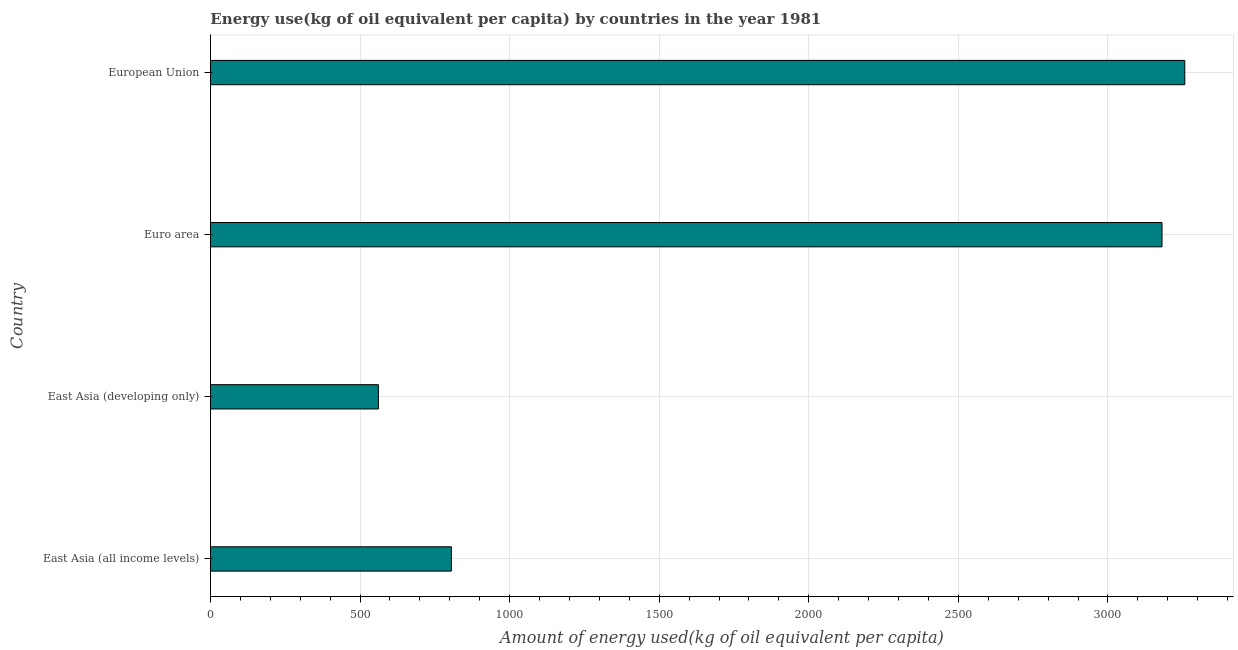Does the graph contain any zero values?
Give a very brief answer. No. What is the title of the graph?
Make the answer very short. Energy use(kg of oil equivalent per capita) by countries in the year 1981. What is the label or title of the X-axis?
Keep it short and to the point. Amount of energy used(kg of oil equivalent per capita). What is the amount of energy used in European Union?
Offer a very short reply. 3256.81. Across all countries, what is the maximum amount of energy used?
Offer a terse response. 3256.81. Across all countries, what is the minimum amount of energy used?
Your answer should be very brief. 561.29. In which country was the amount of energy used maximum?
Make the answer very short. European Union. In which country was the amount of energy used minimum?
Offer a very short reply. East Asia (developing only). What is the sum of the amount of energy used?
Provide a succinct answer. 7804.25. What is the difference between the amount of energy used in East Asia (all income levels) and European Union?
Give a very brief answer. -2451.39. What is the average amount of energy used per country?
Your response must be concise. 1951.06. What is the median amount of energy used?
Offer a terse response. 1993.07. In how many countries, is the amount of energy used greater than 1600 kg?
Provide a short and direct response. 2. What is the ratio of the amount of energy used in East Asia (all income levels) to that in East Asia (developing only)?
Your answer should be very brief. 1.44. Is the difference between the amount of energy used in East Asia (all income levels) and European Union greater than the difference between any two countries?
Keep it short and to the point. No. What is the difference between the highest and the second highest amount of energy used?
Your answer should be compact. 76.08. What is the difference between the highest and the lowest amount of energy used?
Ensure brevity in your answer.  2695.52. How many bars are there?
Keep it short and to the point. 4. What is the difference between two consecutive major ticks on the X-axis?
Make the answer very short. 500. Are the values on the major ticks of X-axis written in scientific E-notation?
Your response must be concise. No. What is the Amount of energy used(kg of oil equivalent per capita) of East Asia (all income levels)?
Give a very brief answer. 805.42. What is the Amount of energy used(kg of oil equivalent per capita) in East Asia (developing only)?
Your answer should be very brief. 561.29. What is the Amount of energy used(kg of oil equivalent per capita) in Euro area?
Give a very brief answer. 3180.73. What is the Amount of energy used(kg of oil equivalent per capita) of European Union?
Provide a short and direct response. 3256.81. What is the difference between the Amount of energy used(kg of oil equivalent per capita) in East Asia (all income levels) and East Asia (developing only)?
Ensure brevity in your answer.  244.14. What is the difference between the Amount of energy used(kg of oil equivalent per capita) in East Asia (all income levels) and Euro area?
Your answer should be compact. -2375.3. What is the difference between the Amount of energy used(kg of oil equivalent per capita) in East Asia (all income levels) and European Union?
Keep it short and to the point. -2451.39. What is the difference between the Amount of energy used(kg of oil equivalent per capita) in East Asia (developing only) and Euro area?
Make the answer very short. -2619.44. What is the difference between the Amount of energy used(kg of oil equivalent per capita) in East Asia (developing only) and European Union?
Offer a terse response. -2695.52. What is the difference between the Amount of energy used(kg of oil equivalent per capita) in Euro area and European Union?
Provide a short and direct response. -76.08. What is the ratio of the Amount of energy used(kg of oil equivalent per capita) in East Asia (all income levels) to that in East Asia (developing only)?
Your answer should be compact. 1.44. What is the ratio of the Amount of energy used(kg of oil equivalent per capita) in East Asia (all income levels) to that in Euro area?
Make the answer very short. 0.25. What is the ratio of the Amount of energy used(kg of oil equivalent per capita) in East Asia (all income levels) to that in European Union?
Offer a very short reply. 0.25. What is the ratio of the Amount of energy used(kg of oil equivalent per capita) in East Asia (developing only) to that in Euro area?
Offer a very short reply. 0.18. What is the ratio of the Amount of energy used(kg of oil equivalent per capita) in East Asia (developing only) to that in European Union?
Provide a succinct answer. 0.17. 